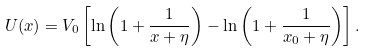Convert formula to latex. <formula><loc_0><loc_0><loc_500><loc_500>U ( x ) = V _ { 0 } \left [ \ln \left ( 1 + \frac { 1 } { x + \eta } \right ) - \ln \left ( 1 + \frac { 1 } { x _ { 0 } + \eta } \right ) \right ] .</formula> 